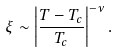<formula> <loc_0><loc_0><loc_500><loc_500>\xi \sim \left | \frac { T - T _ { c } } { T _ { c } } \right | ^ { - \nu } .</formula> 